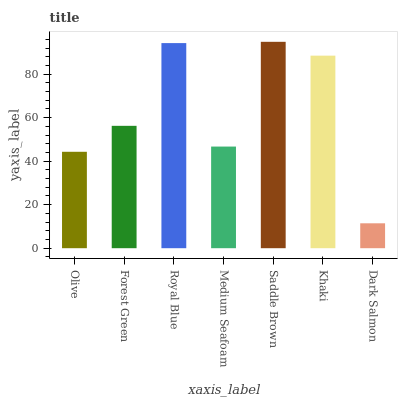Is Dark Salmon the minimum?
Answer yes or no. Yes. Is Saddle Brown the maximum?
Answer yes or no. Yes. Is Forest Green the minimum?
Answer yes or no. No. Is Forest Green the maximum?
Answer yes or no. No. Is Forest Green greater than Olive?
Answer yes or no. Yes. Is Olive less than Forest Green?
Answer yes or no. Yes. Is Olive greater than Forest Green?
Answer yes or no. No. Is Forest Green less than Olive?
Answer yes or no. No. Is Forest Green the high median?
Answer yes or no. Yes. Is Forest Green the low median?
Answer yes or no. Yes. Is Khaki the high median?
Answer yes or no. No. Is Medium Seafoam the low median?
Answer yes or no. No. 